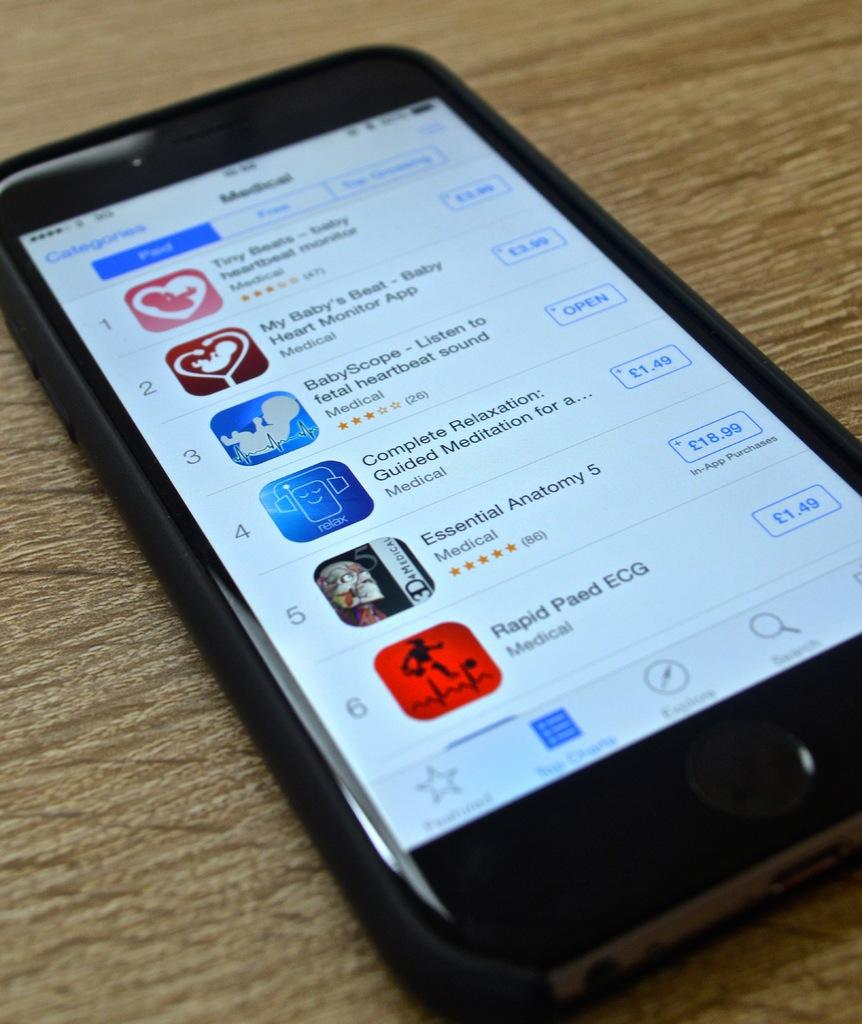<image>
Summarize the visual content of the image. A cellphone showing the many apps on the screen and the purchase price. 